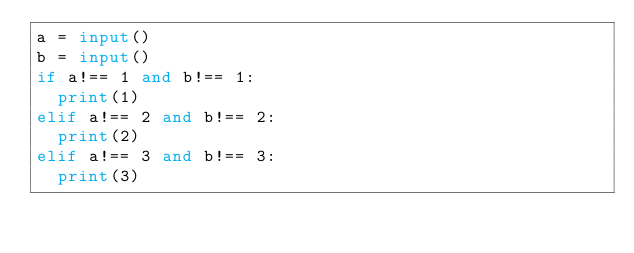Convert code to text. <code><loc_0><loc_0><loc_500><loc_500><_Python_>a = input()
b = input()
if a!== 1 and b!== 1:
  print(1)
elif a!== 2 and b!== 2:
  print(2)
elif a!== 3 and b!== 3:
  print(3)
  </code> 